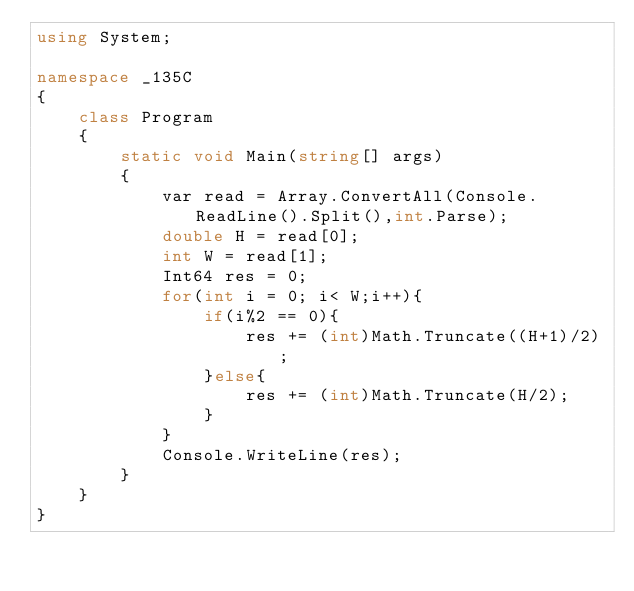<code> <loc_0><loc_0><loc_500><loc_500><_C#_>using System;
 
namespace _135C
{
    class Program
    {
        static void Main(string[] args)
        {
            var read = Array.ConvertAll(Console.ReadLine().Split(),int.Parse);
            double H = read[0];
            int W = read[1];
            Int64 res = 0;
            for(int i = 0; i< W;i++){
                if(i%2 == 0){
                    res += (int)Math.Truncate((H+1)/2);
                }else{
                    res += (int)Math.Truncate(H/2);
                }
            }
            Console.WriteLine(res);
        }
    }
}</code> 